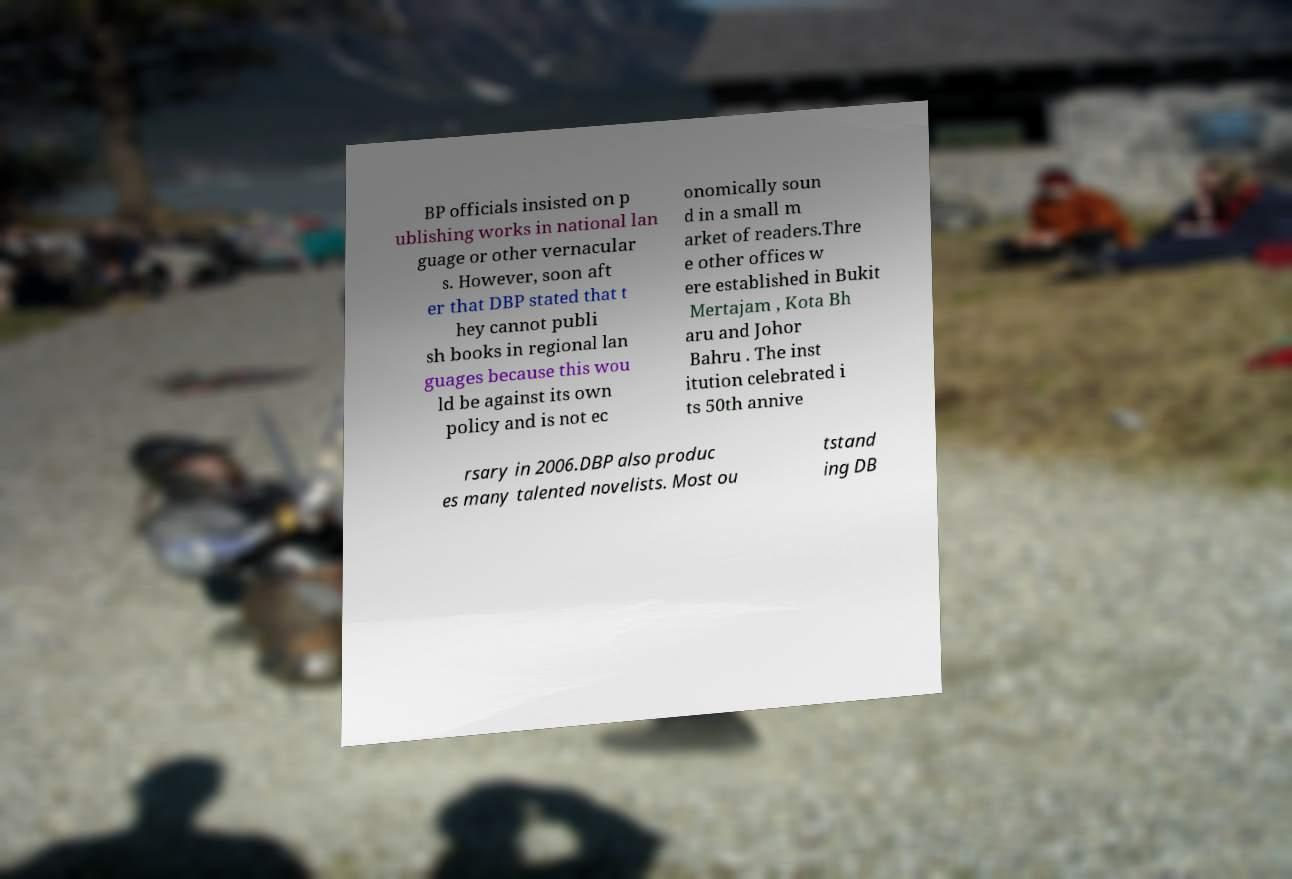Can you read and provide the text displayed in the image?This photo seems to have some interesting text. Can you extract and type it out for me? BP officials insisted on p ublishing works in national lan guage or other vernacular s. However, soon aft er that DBP stated that t hey cannot publi sh books in regional lan guages because this wou ld be against its own policy and is not ec onomically soun d in a small m arket of readers.Thre e other offices w ere established in Bukit Mertajam , Kota Bh aru and Johor Bahru . The inst itution celebrated i ts 50th annive rsary in 2006.DBP also produc es many talented novelists. Most ou tstand ing DB 